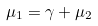<formula> <loc_0><loc_0><loc_500><loc_500>\mu _ { 1 } = \gamma + \mu _ { 2 }</formula> 